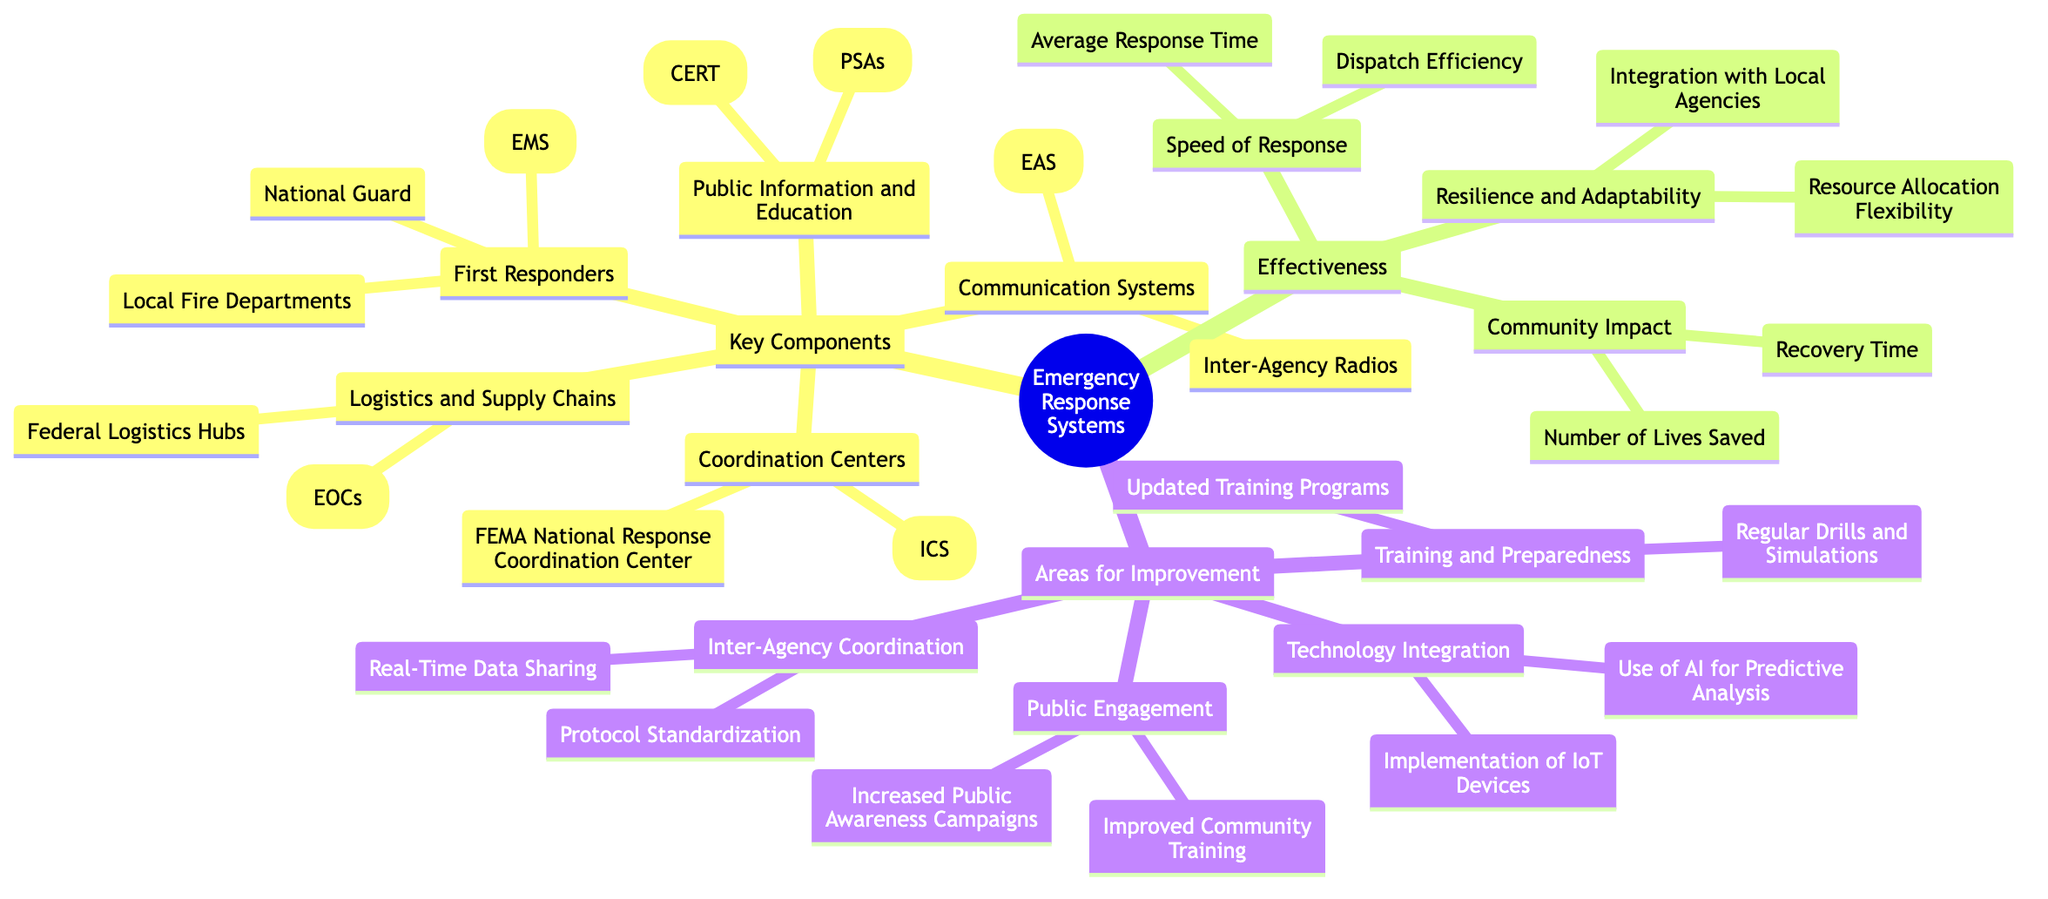What are the two key components under Coordination Centers? The diagram lists two key components under Coordination Centers, which are the FEMA National Response Coordination Center and the Incident Command System (ICS). These are explicitly mentioned in the relevant section.
Answer: FEMA National Response Coordination Center, Incident Command System (ICS) How many first responders are listed? The diagram states that there are three types of first responders which include Local Fire Departments, Emergency Medical Services (EMS), and National Guard. Therefore, by counting these nodes, we arrive at the total.
Answer: 3 What is one area for improvement related to technology? Looking at the Areas for Improvement section, the diagram indicates that one aspect of technology improvement includes "Use of AI for Predictive Analysis," which is specified under Technology Integration.
Answer: Use of AI for Predictive Analysis Which component addresses community education? The Public Information and Education component focuses on educating the community, which lists Community Emergency Response Teams (CERT) and Public Service Announcements (PSAs) as its parts. This connection can be established by directly analyzing the topical areas.
Answer: Public Information and Education What are the two effectiveness criteria that relate to community impact? The diagram lists two criteria related to community impact under Effectiveness: "Number of Lives Saved" and "Recovery Time." By referring to the Effectiveness section and identifying the specific items mentioned, we find the answer.
Answer: Number of Lives Saved, Recovery Time Which two improvements are suggested for Inter-Agency Coordination? The diagram shows that in the Inter-Agency Coordination category, the suggested improvements include "Protocol Standardization" and "Real-Time Data Sharing." To identify these, one references the specific sub-nodes listed.
Answer: Protocol Standardization, Real-Time Data Sharing What does the Speed of Response category focus on? The Speed of Response category highlights two main aspects: Average Response Time and Dispatch Efficiency, specifically named under this heading in the diagram. This identification is made through a close reading of the relevant section.
Answer: Average Response Time, Dispatch Efficiency How does the diagram structure the relationship between Key Components and Effectiveness? The diagram presents Key Components and Effectiveness as separate categories on the same level, indicating they are distinct areas that contribute to a comprehensive view of Emergency Response Systems. Each category encompasses its own nodes that detail specific elements.
Answer: Separate categories 